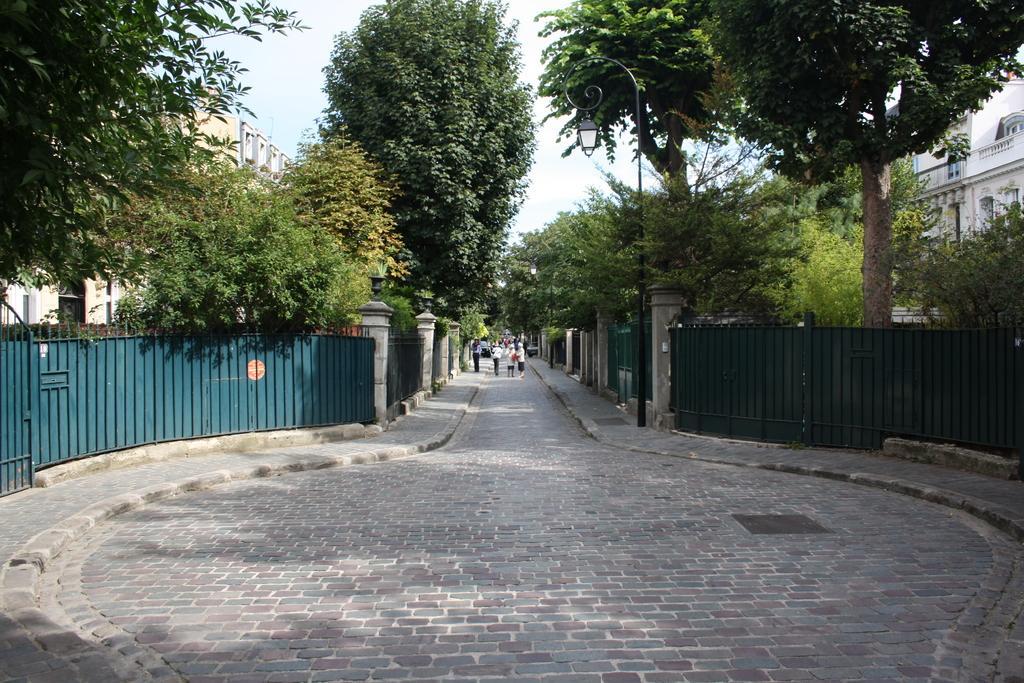Could you give a brief overview of what you see in this image? In this image we can see a group of people standing on the pathway. We can also see the metal fence, a street pole, a group of trees, street lamps on the pillars, some buildings and the sky. 